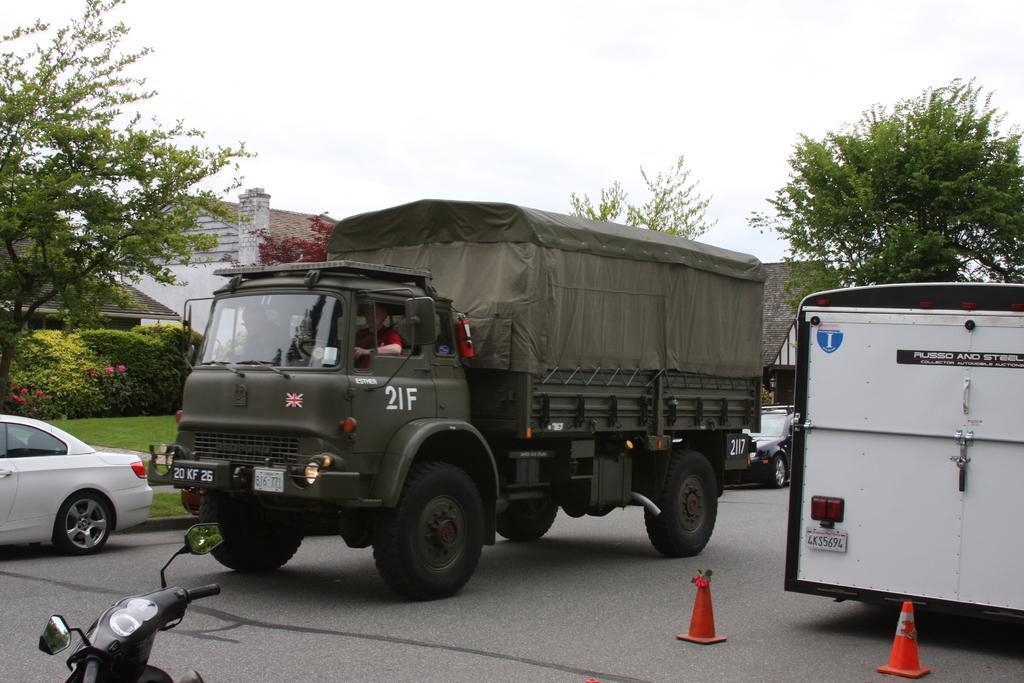Please provide a concise description of this image. In this image we can see a group of vehicles on the road. We can see a person sitting in a truck. We can also see some traffic poles, trees, grass, some plants with flowers, a house with roof and the sky. 